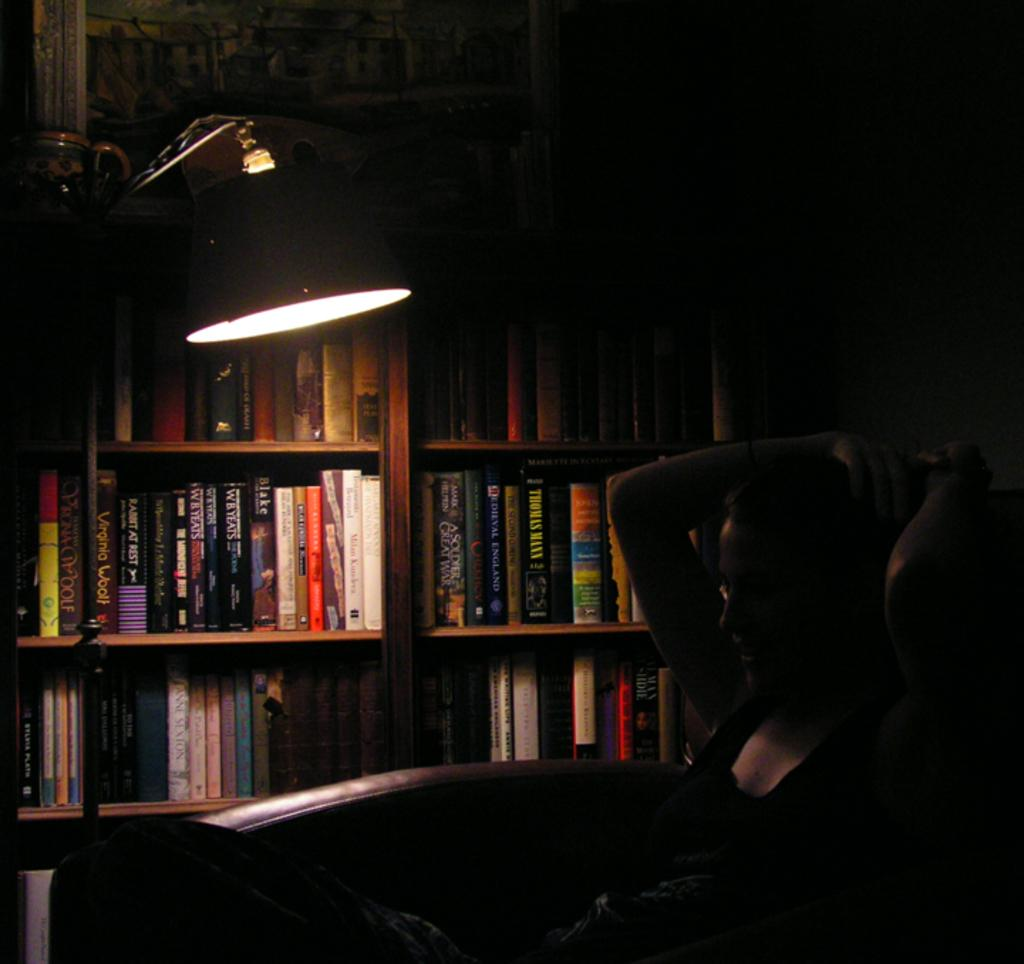Who or what is present in the image? There is a person in the image. What object can be seen in the image besides the person? There is a lamp in the image. What type of items are visible on the shelves or racks in the image? There are books in racks in the image. How would you describe the lighting conditions in the image? The background of the image is dark. What song is the person singing in the image? There is no indication in the image that the person is singing a song, so it cannot be determined from the picture. 